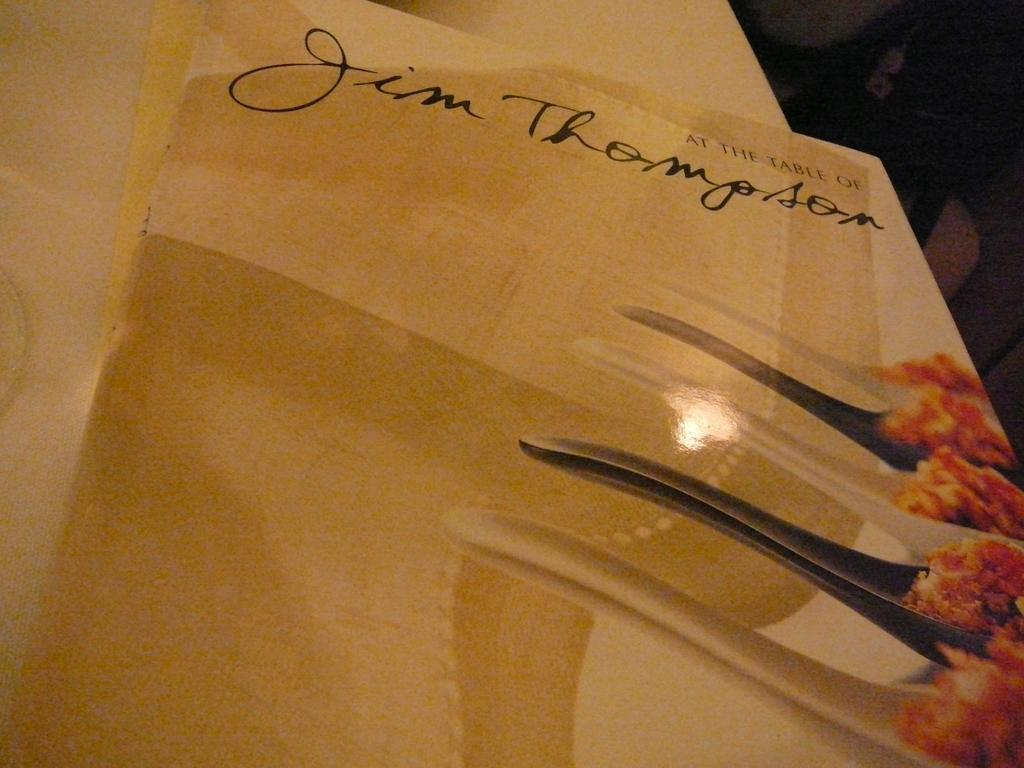What is the main object in the image? There is a card in the image. What color is the card? The card is cream-colored. What can be found on the card? There is writing on the card. Where is the card located? The card is on a surface. How does the snow affect the card in the image? There is no snow present in the image, so it cannot affect the card. 